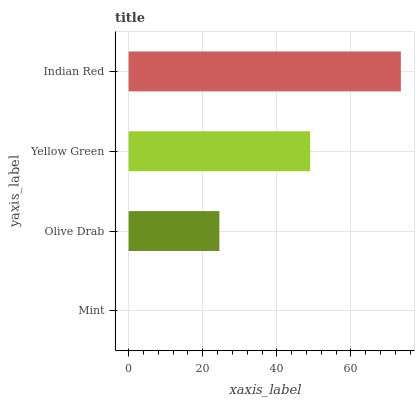Is Mint the minimum?
Answer yes or no. Yes. Is Indian Red the maximum?
Answer yes or no. Yes. Is Olive Drab the minimum?
Answer yes or no. No. Is Olive Drab the maximum?
Answer yes or no. No. Is Olive Drab greater than Mint?
Answer yes or no. Yes. Is Mint less than Olive Drab?
Answer yes or no. Yes. Is Mint greater than Olive Drab?
Answer yes or no. No. Is Olive Drab less than Mint?
Answer yes or no. No. Is Yellow Green the high median?
Answer yes or no. Yes. Is Olive Drab the low median?
Answer yes or no. Yes. Is Mint the high median?
Answer yes or no. No. Is Mint the low median?
Answer yes or no. No. 